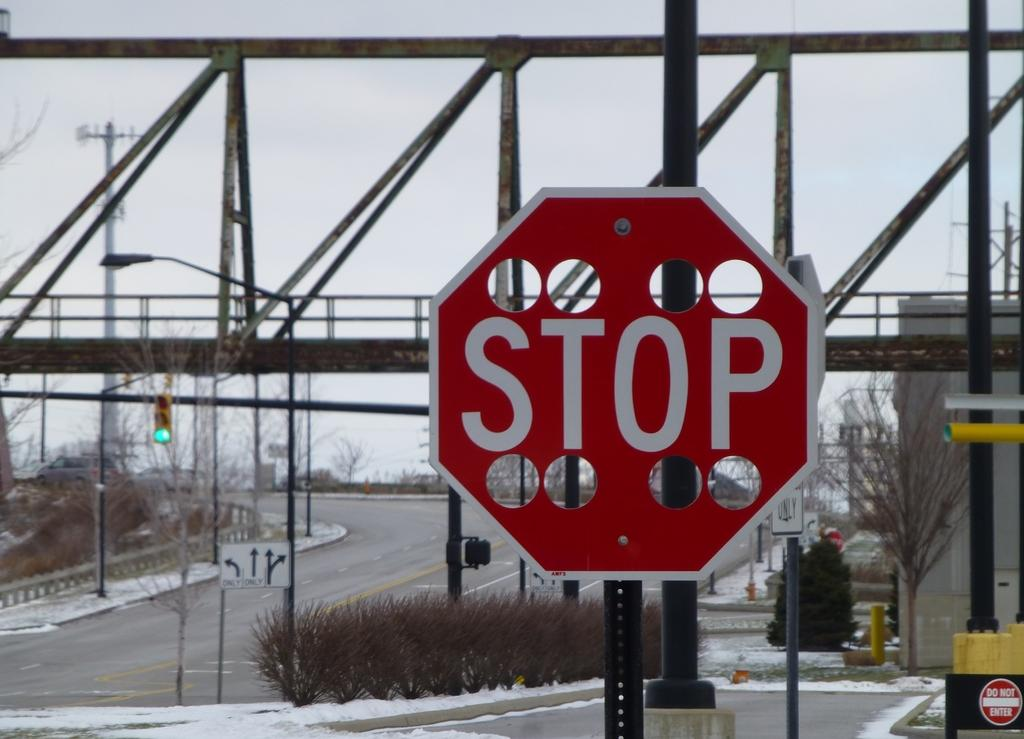<image>
Share a concise interpretation of the image provided. a stop sign that is outside in the daytime 